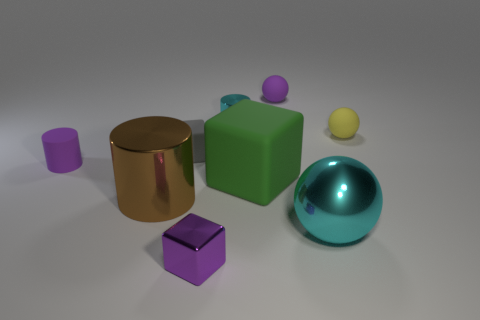Do the big metallic ball and the tiny metal cylinder have the same color?
Offer a terse response. Yes. There is a small block in front of the brown shiny thing; is its color the same as the small matte cylinder?
Offer a terse response. Yes. What number of matte objects are brown cylinders or big brown blocks?
Offer a terse response. 0. What is the shape of the brown object?
Ensure brevity in your answer.  Cylinder. Is the big cylinder made of the same material as the tiny yellow thing?
Offer a very short reply. No. Is there a metallic ball on the left side of the cyan object that is behind the shiny object that is left of the purple cube?
Offer a very short reply. No. How many other objects are there of the same shape as the yellow matte object?
Your answer should be compact. 2. There is a thing that is both to the left of the gray object and in front of the big green rubber thing; what is its shape?
Give a very brief answer. Cylinder. What is the color of the small matte object that is to the left of the shiny cylinder in front of the sphere that is on the right side of the big metal sphere?
Give a very brief answer. Purple. Is the number of big shiny cylinders that are to the right of the green block greater than the number of large rubber things that are to the left of the gray rubber thing?
Keep it short and to the point. No. 